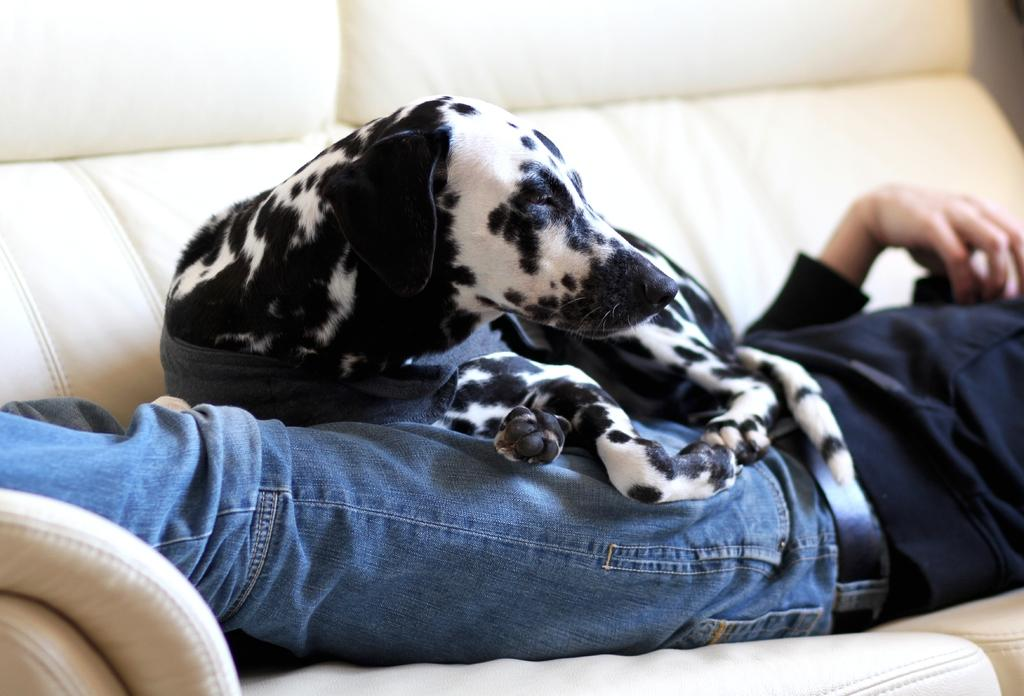Where was the image taken? The image is taken indoors. What piece of furniture is at the bottom of the image? There is a couch at the bottom of the image. What is the man in the image doing? A man is lying on the couch. What is sitting on the man in the image? There is a dog sitting on the man. What is the tendency of the man's teeth in the image? There is no mention of the man's teeth in the image, so it is impossible to determine their tendency. 